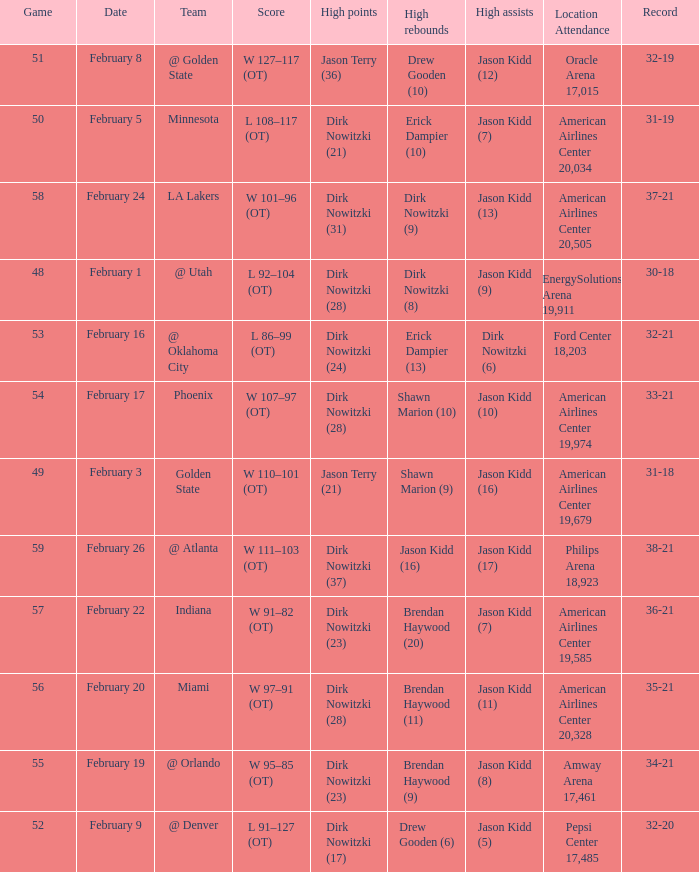Who had the most high assists with a record of 32-19? Jason Kidd (12). 